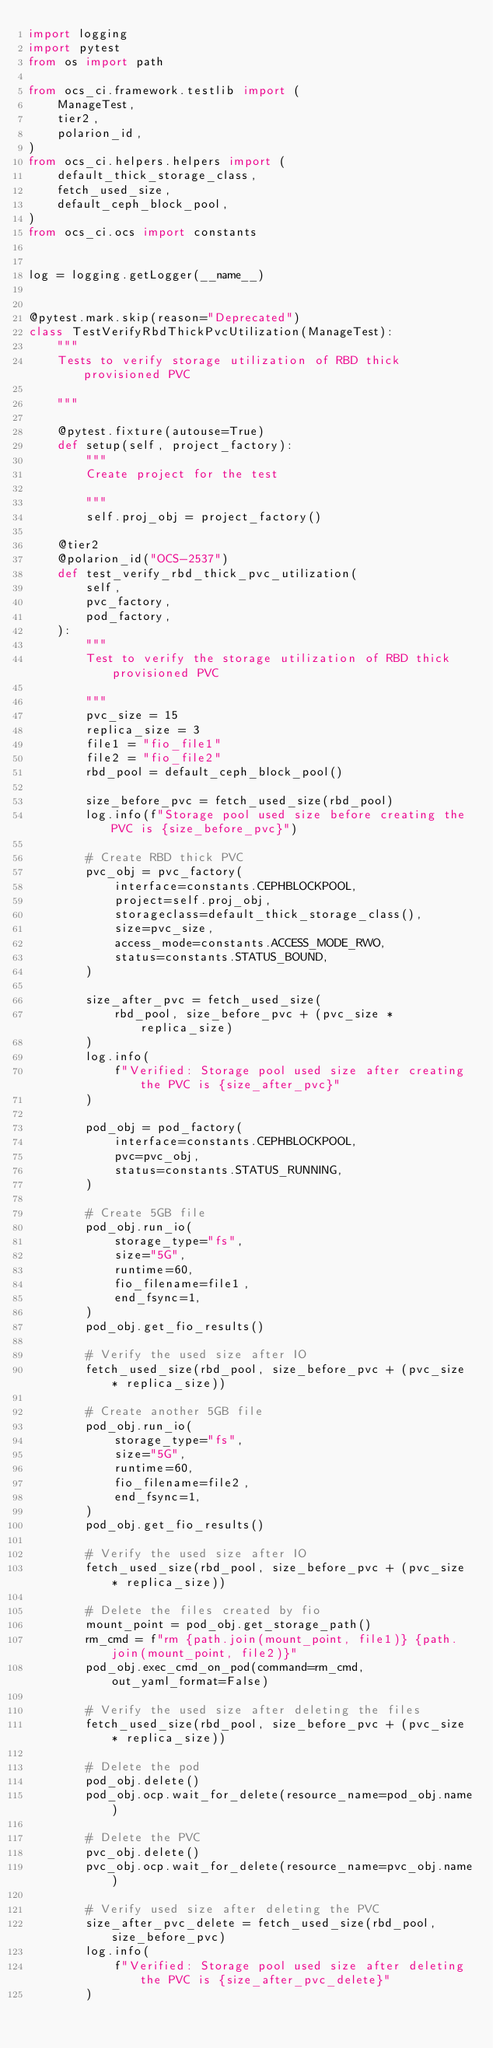Convert code to text. <code><loc_0><loc_0><loc_500><loc_500><_Python_>import logging
import pytest
from os import path

from ocs_ci.framework.testlib import (
    ManageTest,
    tier2,
    polarion_id,
)
from ocs_ci.helpers.helpers import (
    default_thick_storage_class,
    fetch_used_size,
    default_ceph_block_pool,
)
from ocs_ci.ocs import constants


log = logging.getLogger(__name__)


@pytest.mark.skip(reason="Deprecated")
class TestVerifyRbdThickPvcUtilization(ManageTest):
    """
    Tests to verify storage utilization of RBD thick provisioned PVC

    """

    @pytest.fixture(autouse=True)
    def setup(self, project_factory):
        """
        Create project for the test

        """
        self.proj_obj = project_factory()

    @tier2
    @polarion_id("OCS-2537")
    def test_verify_rbd_thick_pvc_utilization(
        self,
        pvc_factory,
        pod_factory,
    ):
        """
        Test to verify the storage utilization of RBD thick provisioned PVC

        """
        pvc_size = 15
        replica_size = 3
        file1 = "fio_file1"
        file2 = "fio_file2"
        rbd_pool = default_ceph_block_pool()

        size_before_pvc = fetch_used_size(rbd_pool)
        log.info(f"Storage pool used size before creating the PVC is {size_before_pvc}")

        # Create RBD thick PVC
        pvc_obj = pvc_factory(
            interface=constants.CEPHBLOCKPOOL,
            project=self.proj_obj,
            storageclass=default_thick_storage_class(),
            size=pvc_size,
            access_mode=constants.ACCESS_MODE_RWO,
            status=constants.STATUS_BOUND,
        )

        size_after_pvc = fetch_used_size(
            rbd_pool, size_before_pvc + (pvc_size * replica_size)
        )
        log.info(
            f"Verified: Storage pool used size after creating the PVC is {size_after_pvc}"
        )

        pod_obj = pod_factory(
            interface=constants.CEPHBLOCKPOOL,
            pvc=pvc_obj,
            status=constants.STATUS_RUNNING,
        )

        # Create 5GB file
        pod_obj.run_io(
            storage_type="fs",
            size="5G",
            runtime=60,
            fio_filename=file1,
            end_fsync=1,
        )
        pod_obj.get_fio_results()

        # Verify the used size after IO
        fetch_used_size(rbd_pool, size_before_pvc + (pvc_size * replica_size))

        # Create another 5GB file
        pod_obj.run_io(
            storage_type="fs",
            size="5G",
            runtime=60,
            fio_filename=file2,
            end_fsync=1,
        )
        pod_obj.get_fio_results()

        # Verify the used size after IO
        fetch_used_size(rbd_pool, size_before_pvc + (pvc_size * replica_size))

        # Delete the files created by fio
        mount_point = pod_obj.get_storage_path()
        rm_cmd = f"rm {path.join(mount_point, file1)} {path.join(mount_point, file2)}"
        pod_obj.exec_cmd_on_pod(command=rm_cmd, out_yaml_format=False)

        # Verify the used size after deleting the files
        fetch_used_size(rbd_pool, size_before_pvc + (pvc_size * replica_size))

        # Delete the pod
        pod_obj.delete()
        pod_obj.ocp.wait_for_delete(resource_name=pod_obj.name)

        # Delete the PVC
        pvc_obj.delete()
        pvc_obj.ocp.wait_for_delete(resource_name=pvc_obj.name)

        # Verify used size after deleting the PVC
        size_after_pvc_delete = fetch_used_size(rbd_pool, size_before_pvc)
        log.info(
            f"Verified: Storage pool used size after deleting the PVC is {size_after_pvc_delete}"
        )
</code> 